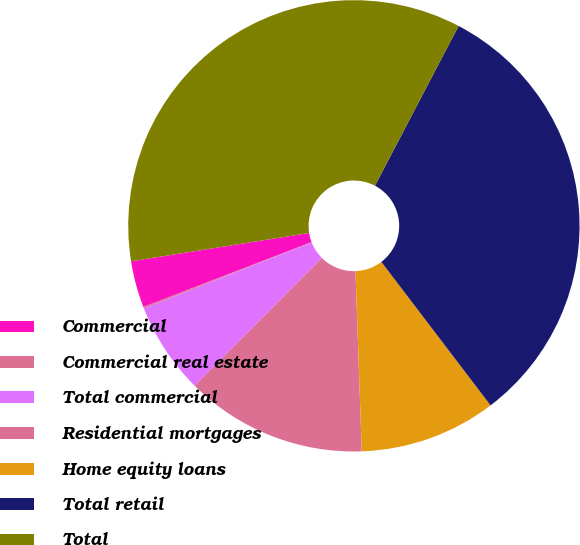Convert chart to OTSL. <chart><loc_0><loc_0><loc_500><loc_500><pie_chart><fcel>Commercial<fcel>Commercial real estate<fcel>Total commercial<fcel>Residential mortgages<fcel>Home equity loans<fcel>Total retail<fcel>Total<nl><fcel>3.34%<fcel>0.11%<fcel>6.57%<fcel>13.02%<fcel>9.8%<fcel>31.96%<fcel>35.19%<nl></chart> 